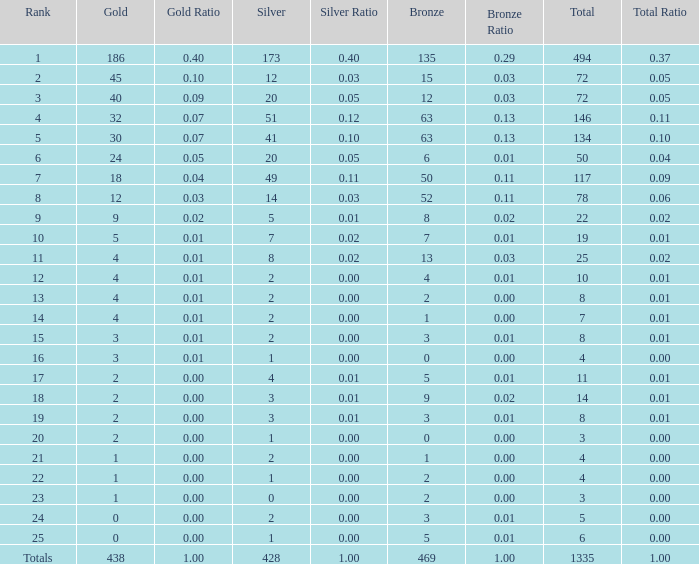What is the number of bronze medals when the total medals were 78 and there were less than 12 golds? None. 